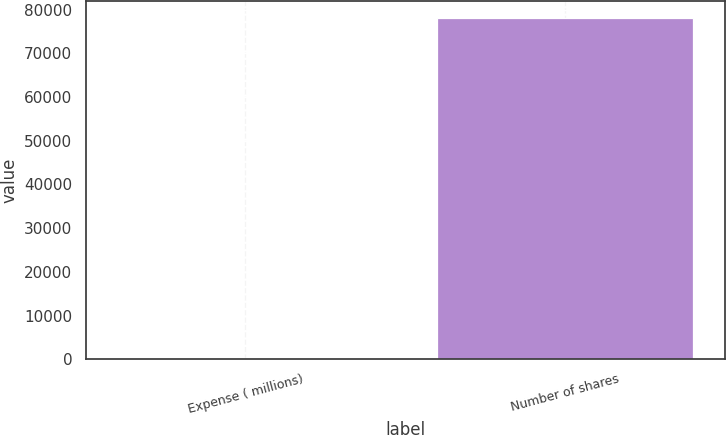Convert chart to OTSL. <chart><loc_0><loc_0><loc_500><loc_500><bar_chart><fcel>Expense ( millions)<fcel>Number of shares<nl><fcel>2.2<fcel>78170<nl></chart> 